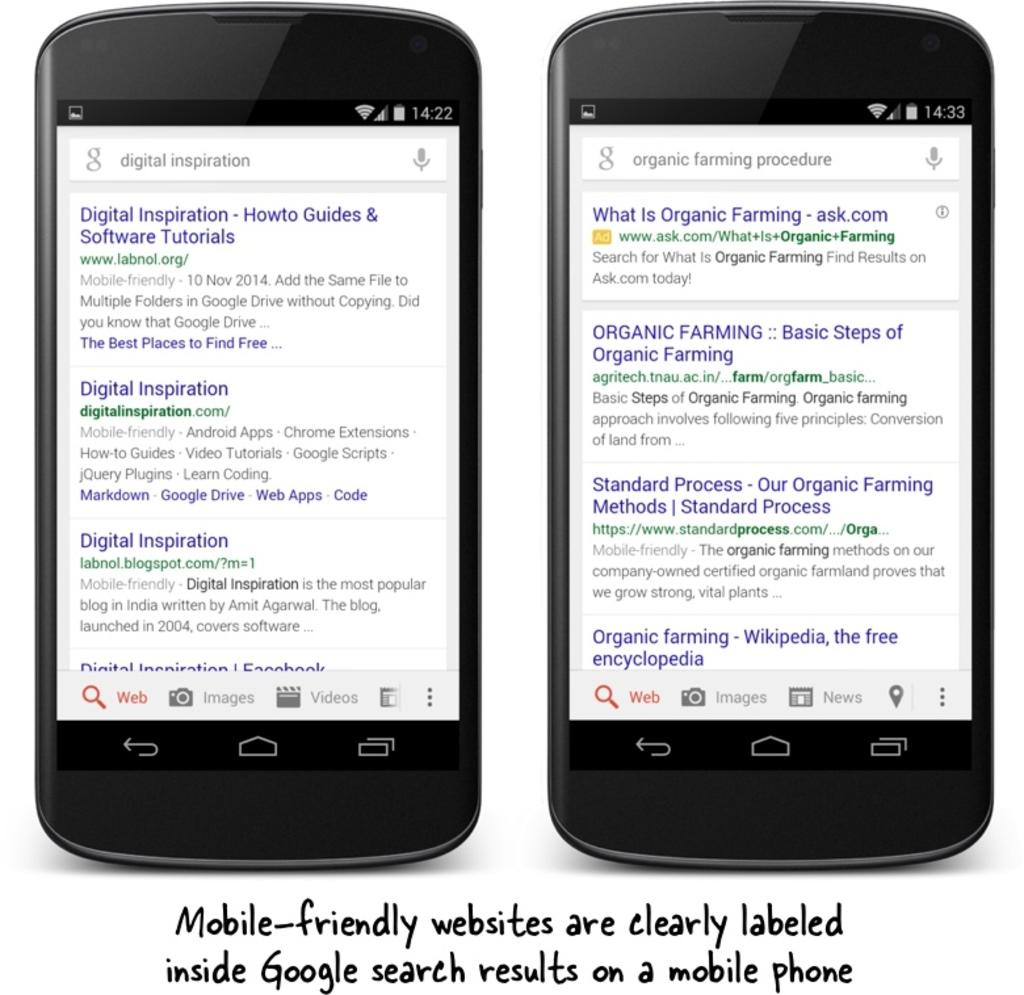<image>
Render a clear and concise summary of the photo. Below two smartphones there is text about google search results. 